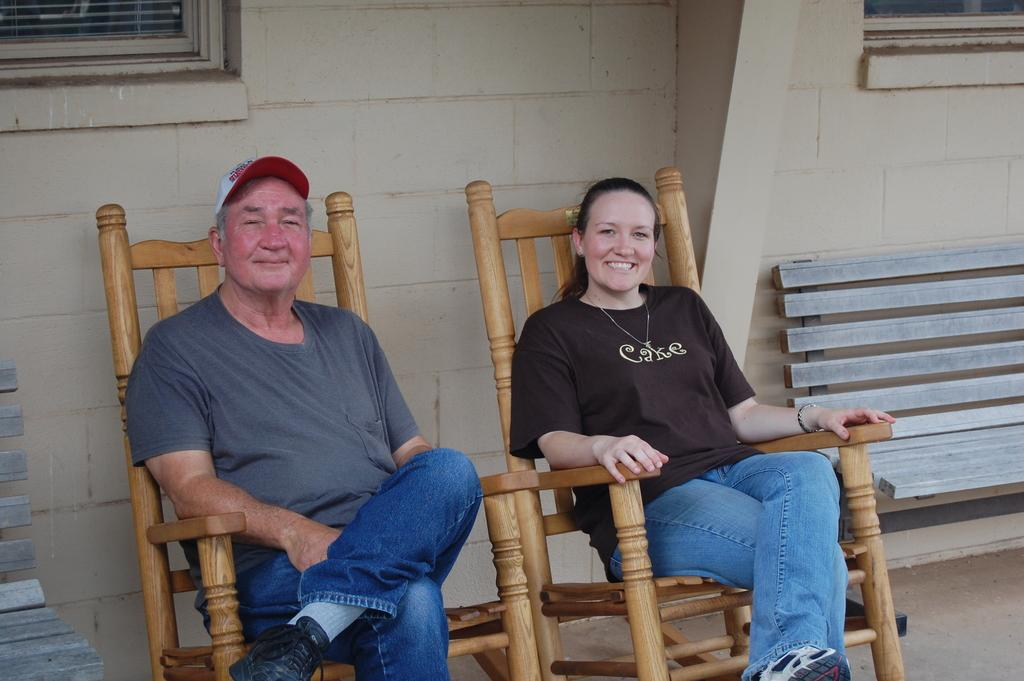How many people are in the image? There are two people in the image. What are the two people doing in the image? The two people are sitting on a chair. Are there any other chairs visible in the image? Yes, there is an unoccupied chair to the right of the image. What type of glue is being used by the person on the left in the image? There is no glue present in the image, and therefore no such activity can be observed. 